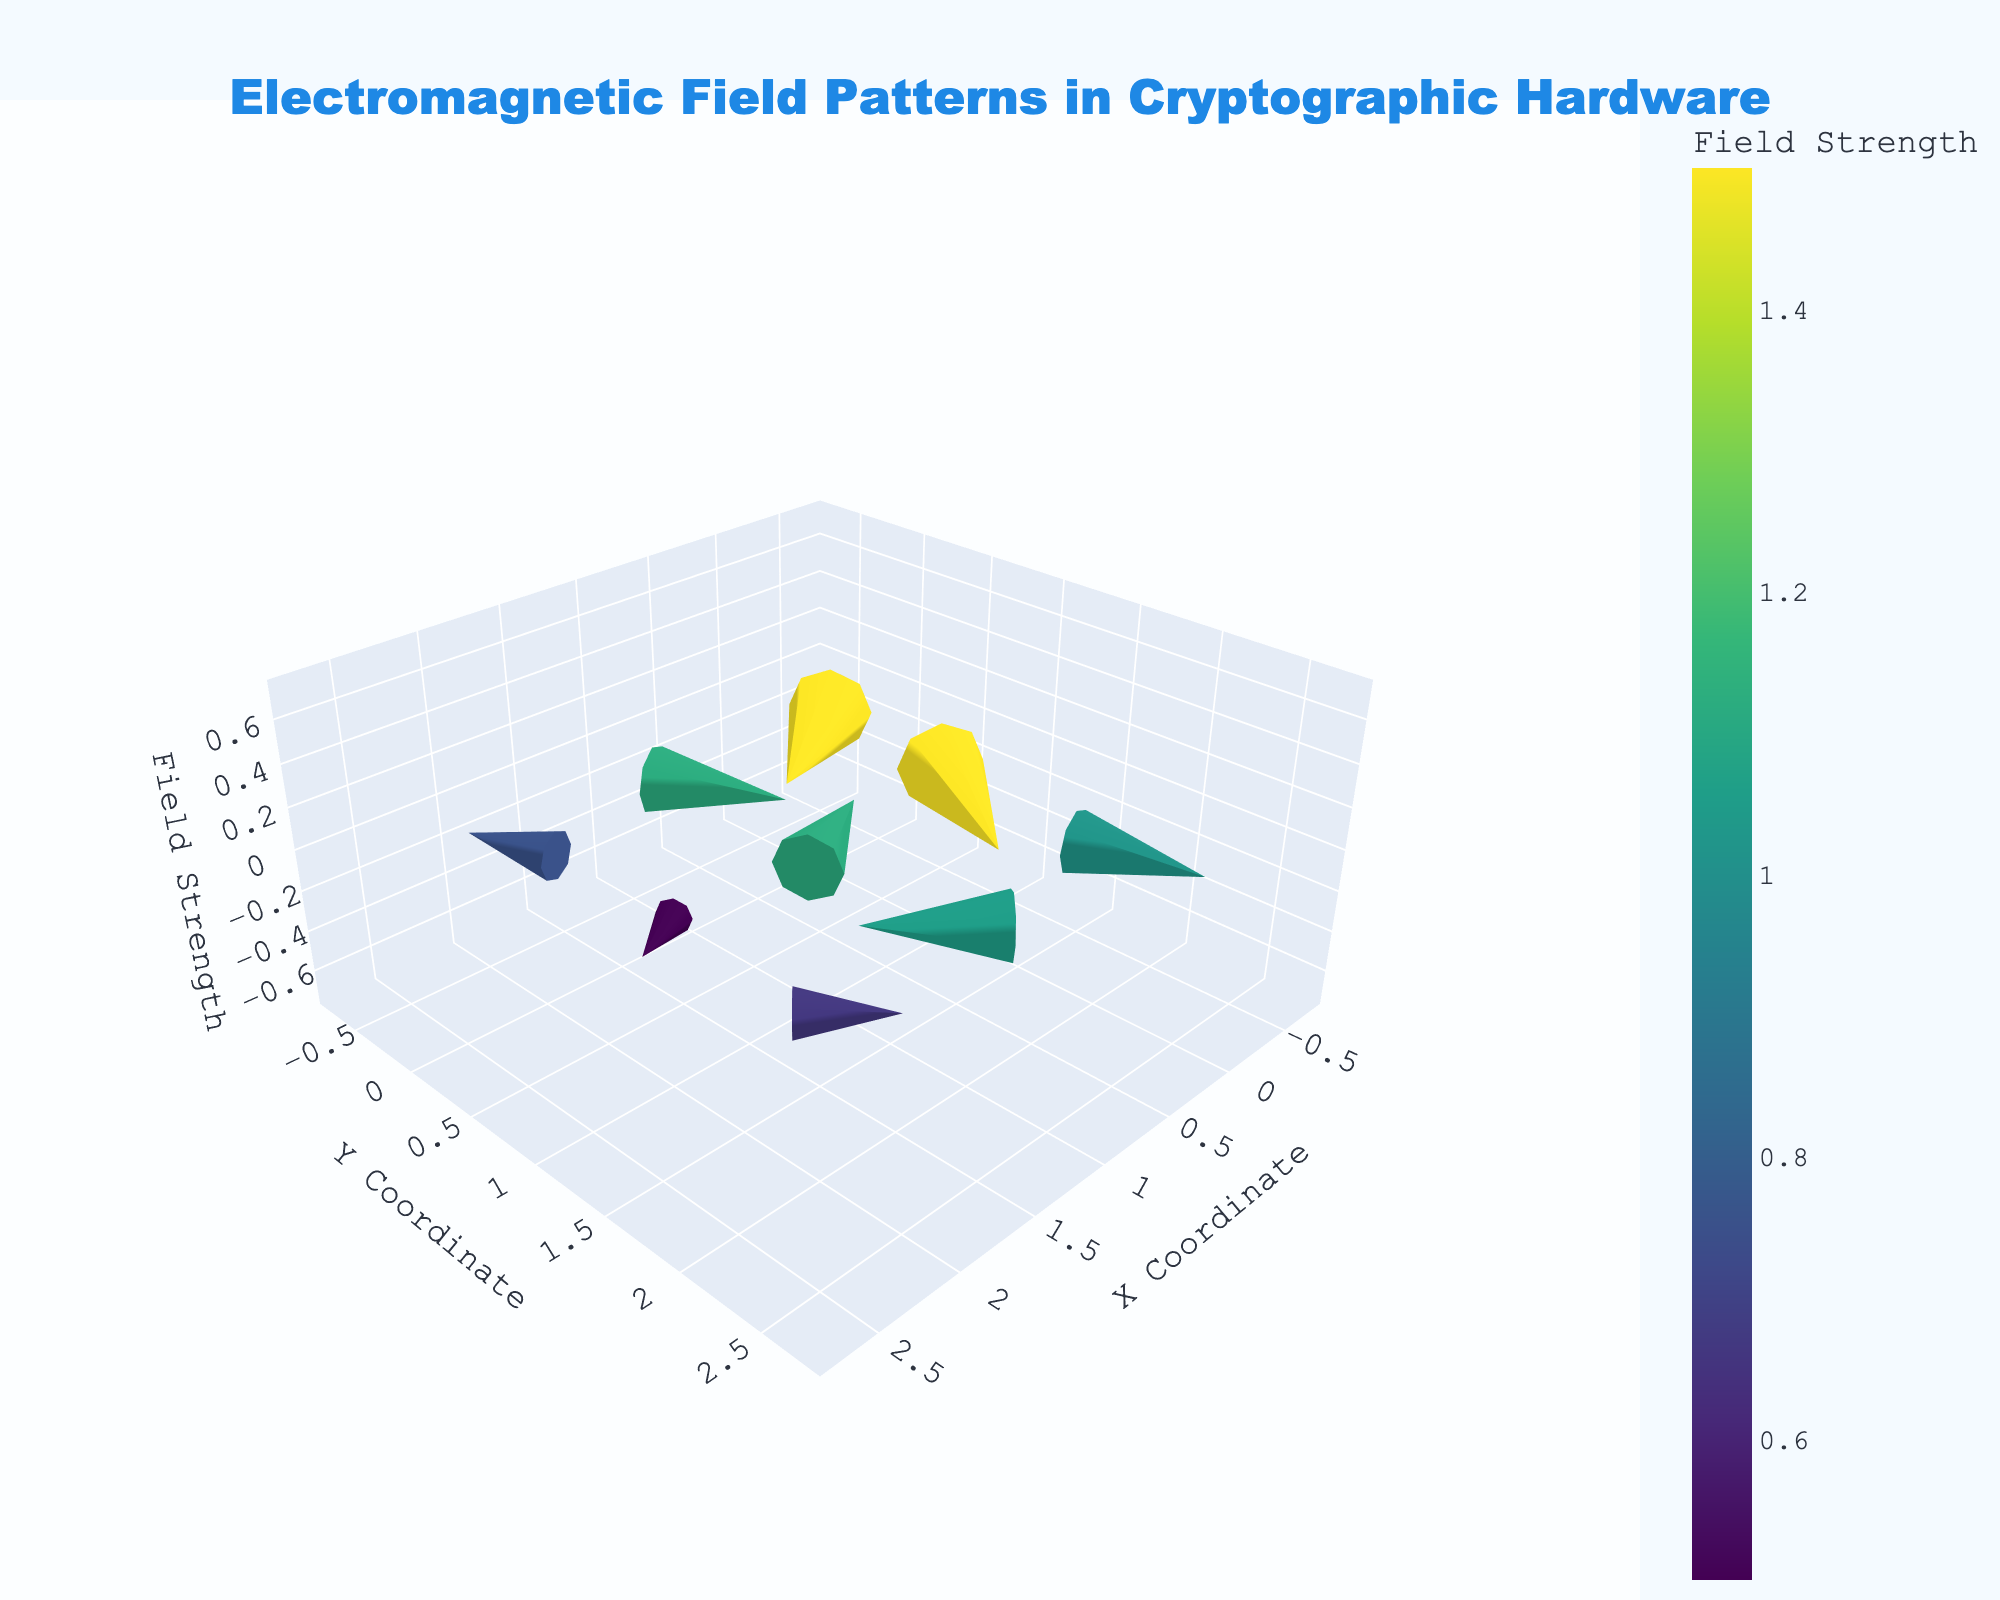what is the title of the figure? The title is located at the top of the figure. It reads, "Electromagnetic Field Patterns in Cryptographic Hardware."
Answer: Electromagnetic Field Patterns in Cryptographic Hardware What coordinates does the longest vector start from? To determine this, observe which vector has the longest visible length among all. The vector starting from (0, 1) has the longest visible length.
Answer: (0, 1) Which axis represents the field strength in the figure? Look at the axis titles provided. The z-axis is labeled "Field Strength."
Answer: z-axis What colors are used to represent the field strength? Observing the color scale and the markers in the plot, the colors range from blue to yellow-green, following the Viridis color scale scheme.
Answer: Blue to Yellow-Green What is the field strength at the coordinate (2, 0)? Hover over the coordinate (2, 0) or refer to the marker size/color. The strength is labeled 0.6.
Answer: 0.6 Compare the vector directions at coordinates (1, 0) and (1, 2). Which one points more upwards? Check the v-component of each vector. The vector at (1, 0) is (−0.2, 0.4), indicating a positive y-component (upward). For (1, 2), the vector is (0.3, -0.3), indicating a negative y-component (downward). Thus, (1, 0) points more upwards.
Answer: (1, 0) What is the average field strength of the vectors starting at the x-coordinate 1? The vectors at x=1 have strengths of 0.8 (1, 0), 1.0 (1, 1), and 1.1 (1, 2). The average is calculated as (0.8 + 1.0 + 1.1) / 3 = 0.9667.
Answer: 0.97 Which vector appears the shortest, and what are its coordinates? To find this, identify the smallest visible vector. The vector at (2, 2) with components (-0.2, 0.2) appears the shortest.
Answer: (2, 2) What is the direction of the vector at coordinate (0, 2)? The vector at (0, 2) has components (-0.1, 0.4). This direction has a negative x-component (left) and a positive y-component (upward).
Answer: Left-Upward 